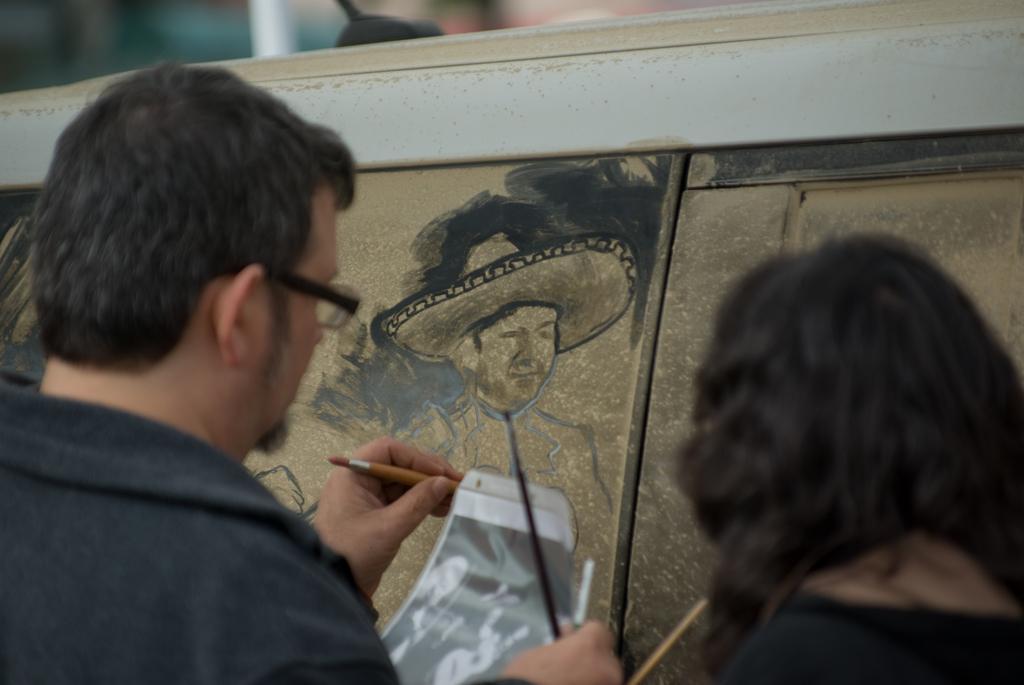Could you give a brief overview of what you see in this image? On the left side there is a person wearing specs is holding a photo and brushes. On the right side there is a lady. In the back there is a board. On the board the person is painting. 